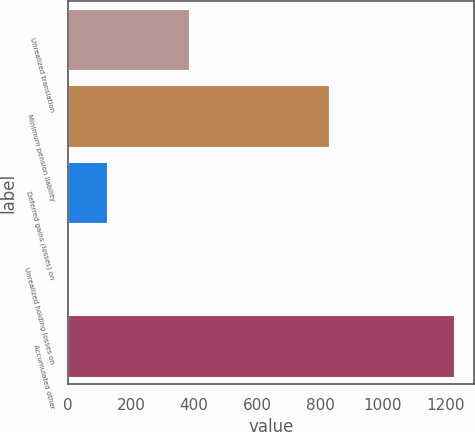<chart> <loc_0><loc_0><loc_500><loc_500><bar_chart><fcel>Unrealized translation<fcel>Minimum pension liability<fcel>Deferred gains (losses) on<fcel>Unrealized holding losses on<fcel>Accumulated other<nl><fcel>385.3<fcel>829.6<fcel>122.78<fcel>0.2<fcel>1226<nl></chart> 